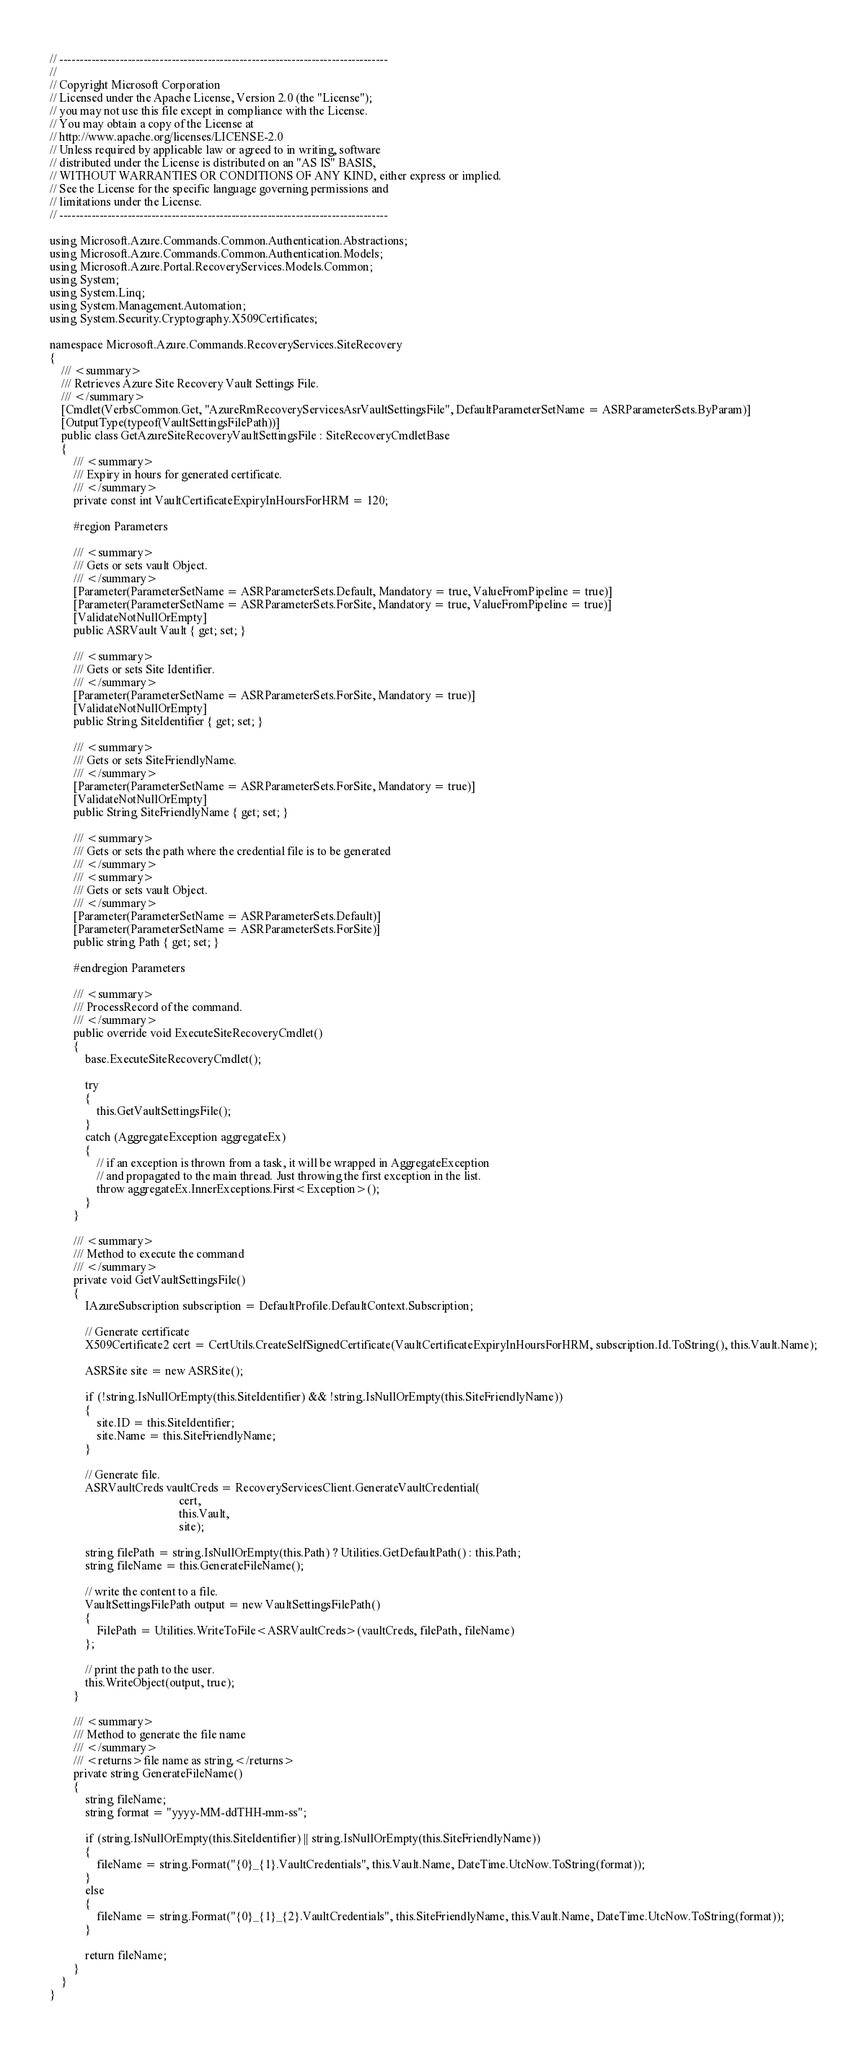Convert code to text. <code><loc_0><loc_0><loc_500><loc_500><_C#_>// ----------------------------------------------------------------------------------
//
// Copyright Microsoft Corporation
// Licensed under the Apache License, Version 2.0 (the "License");
// you may not use this file except in compliance with the License.
// You may obtain a copy of the License at
// http://www.apache.org/licenses/LICENSE-2.0
// Unless required by applicable law or agreed to in writing, software
// distributed under the License is distributed on an "AS IS" BASIS,
// WITHOUT WARRANTIES OR CONDITIONS OF ANY KIND, either express or implied.
// See the License for the specific language governing permissions and
// limitations under the License.
// ----------------------------------------------------------------------------------

using Microsoft.Azure.Commands.Common.Authentication.Abstractions;
using Microsoft.Azure.Commands.Common.Authentication.Models;
using Microsoft.Azure.Portal.RecoveryServices.Models.Common;
using System;
using System.Linq;
using System.Management.Automation;
using System.Security.Cryptography.X509Certificates;

namespace Microsoft.Azure.Commands.RecoveryServices.SiteRecovery
{
    /// <summary>
    /// Retrieves Azure Site Recovery Vault Settings File.
    /// </summary>
    [Cmdlet(VerbsCommon.Get, "AzureRmRecoveryServicesAsrVaultSettingsFile", DefaultParameterSetName = ASRParameterSets.ByParam)]
    [OutputType(typeof(VaultSettingsFilePath))]
    public class GetAzureSiteRecoveryVaultSettingsFile : SiteRecoveryCmdletBase
    {
        /// <summary>
        /// Expiry in hours for generated certificate.
        /// </summary>
        private const int VaultCertificateExpiryInHoursForHRM = 120;

        #region Parameters

        /// <summary>
        /// Gets or sets vault Object.
        /// </summary>
        [Parameter(ParameterSetName = ASRParameterSets.Default, Mandatory = true, ValueFromPipeline = true)]
        [Parameter(ParameterSetName = ASRParameterSets.ForSite, Mandatory = true, ValueFromPipeline = true)]
        [ValidateNotNullOrEmpty]
        public ASRVault Vault { get; set; }

        /// <summary>
        /// Gets or sets Site Identifier.
        /// </summary>
        [Parameter(ParameterSetName = ASRParameterSets.ForSite, Mandatory = true)]
        [ValidateNotNullOrEmpty]
        public String SiteIdentifier { get; set; }

        /// <summary>
        /// Gets or sets SiteFriendlyName.
        /// </summary>
        [Parameter(ParameterSetName = ASRParameterSets.ForSite, Mandatory = true)]
        [ValidateNotNullOrEmpty]
        public String SiteFriendlyName { get; set; }

        /// <summary>
        /// Gets or sets the path where the credential file is to be generated
        /// </summary>
        /// <summary>
        /// Gets or sets vault Object.
        /// </summary>
        [Parameter(ParameterSetName = ASRParameterSets.Default)]
        [Parameter(ParameterSetName = ASRParameterSets.ForSite)]
        public string Path { get; set; }

        #endregion Parameters

        /// <summary>
        /// ProcessRecord of the command.
        /// </summary>
        public override void ExecuteSiteRecoveryCmdlet()
        {
            base.ExecuteSiteRecoveryCmdlet();

            try
            {
                this.GetVaultSettingsFile();
            }
            catch (AggregateException aggregateEx)
            {
                // if an exception is thrown from a task, it will be wrapped in AggregateException 
                // and propagated to the main thread. Just throwing the first exception in the list.
                throw aggregateEx.InnerExceptions.First<Exception>();
            }
        }

        /// <summary>
        /// Method to execute the command
        /// </summary>
        private void GetVaultSettingsFile()
        {
            IAzureSubscription subscription = DefaultProfile.DefaultContext.Subscription;

            // Generate certificate
            X509Certificate2 cert = CertUtils.CreateSelfSignedCertificate(VaultCertificateExpiryInHoursForHRM, subscription.Id.ToString(), this.Vault.Name);

            ASRSite site = new ASRSite();

            if (!string.IsNullOrEmpty(this.SiteIdentifier) && !string.IsNullOrEmpty(this.SiteFriendlyName))
            {
                site.ID = this.SiteIdentifier;
                site.Name = this.SiteFriendlyName;
            }

            // Generate file.
            ASRVaultCreds vaultCreds = RecoveryServicesClient.GenerateVaultCredential(
                                            cert,
                                            this.Vault,
                                            site);

            string filePath = string.IsNullOrEmpty(this.Path) ? Utilities.GetDefaultPath() : this.Path;
            string fileName = this.GenerateFileName();

            // write the content to a file.
            VaultSettingsFilePath output = new VaultSettingsFilePath()
            {
                FilePath = Utilities.WriteToFile<ASRVaultCreds>(vaultCreds, filePath, fileName)
            };

            // print the path to the user.
            this.WriteObject(output, true);
        }

        /// <summary>
        /// Method to generate the file name
        /// </summary>
        /// <returns>file name as string.</returns>
        private string GenerateFileName()
        {
            string fileName;
            string format = "yyyy-MM-ddTHH-mm-ss";

            if (string.IsNullOrEmpty(this.SiteIdentifier) || string.IsNullOrEmpty(this.SiteFriendlyName))
            {
                fileName = string.Format("{0}_{1}.VaultCredentials", this.Vault.Name, DateTime.UtcNow.ToString(format));
            }
            else
            {
                fileName = string.Format("{0}_{1}_{2}.VaultCredentials", this.SiteFriendlyName, this.Vault.Name, DateTime.UtcNow.ToString(format));
            }

            return fileName;
        }
    }
}
</code> 